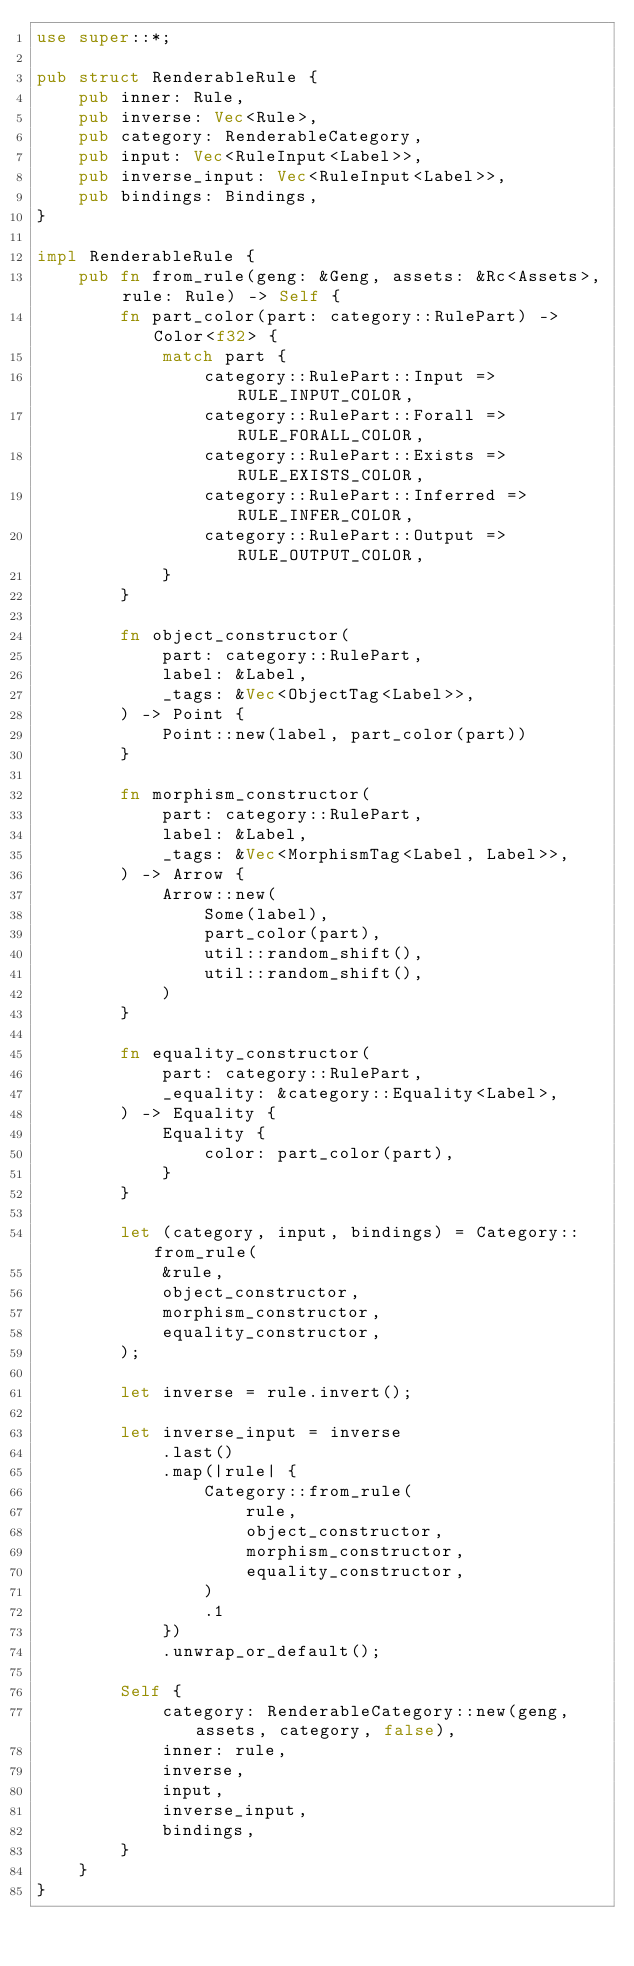<code> <loc_0><loc_0><loc_500><loc_500><_Rust_>use super::*;

pub struct RenderableRule {
    pub inner: Rule,
    pub inverse: Vec<Rule>,
    pub category: RenderableCategory,
    pub input: Vec<RuleInput<Label>>,
    pub inverse_input: Vec<RuleInput<Label>>,
    pub bindings: Bindings,
}

impl RenderableRule {
    pub fn from_rule(geng: &Geng, assets: &Rc<Assets>, rule: Rule) -> Self {
        fn part_color(part: category::RulePart) -> Color<f32> {
            match part {
                category::RulePart::Input => RULE_INPUT_COLOR,
                category::RulePart::Forall => RULE_FORALL_COLOR,
                category::RulePart::Exists => RULE_EXISTS_COLOR,
                category::RulePart::Inferred => RULE_INFER_COLOR,
                category::RulePart::Output => RULE_OUTPUT_COLOR,
            }
        }

        fn object_constructor(
            part: category::RulePart,
            label: &Label,
            _tags: &Vec<ObjectTag<Label>>,
        ) -> Point {
            Point::new(label, part_color(part))
        }

        fn morphism_constructor(
            part: category::RulePart,
            label: &Label,
            _tags: &Vec<MorphismTag<Label, Label>>,
        ) -> Arrow {
            Arrow::new(
                Some(label),
                part_color(part),
                util::random_shift(),
                util::random_shift(),
            )
        }

        fn equality_constructor(
            part: category::RulePart,
            _equality: &category::Equality<Label>,
        ) -> Equality {
            Equality {
                color: part_color(part),
            }
        }

        let (category, input, bindings) = Category::from_rule(
            &rule,
            object_constructor,
            morphism_constructor,
            equality_constructor,
        );

        let inverse = rule.invert();

        let inverse_input = inverse
            .last()
            .map(|rule| {
                Category::from_rule(
                    rule,
                    object_constructor,
                    morphism_constructor,
                    equality_constructor,
                )
                .1
            })
            .unwrap_or_default();

        Self {
            category: RenderableCategory::new(geng, assets, category, false),
            inner: rule,
            inverse,
            input,
            inverse_input,
            bindings,
        }
    }
}
</code> 